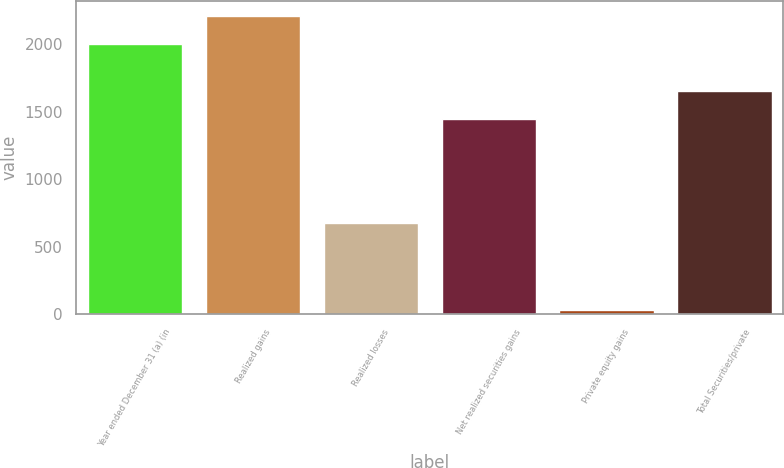<chart> <loc_0><loc_0><loc_500><loc_500><bar_chart><fcel>Year ended December 31 (a) (in<fcel>Realized gains<fcel>Realized losses<fcel>Net realized securities gains<fcel>Private equity gains<fcel>Total Securities/private<nl><fcel>2003<fcel>2212<fcel>677<fcel>1446<fcel>33<fcel>1655<nl></chart> 